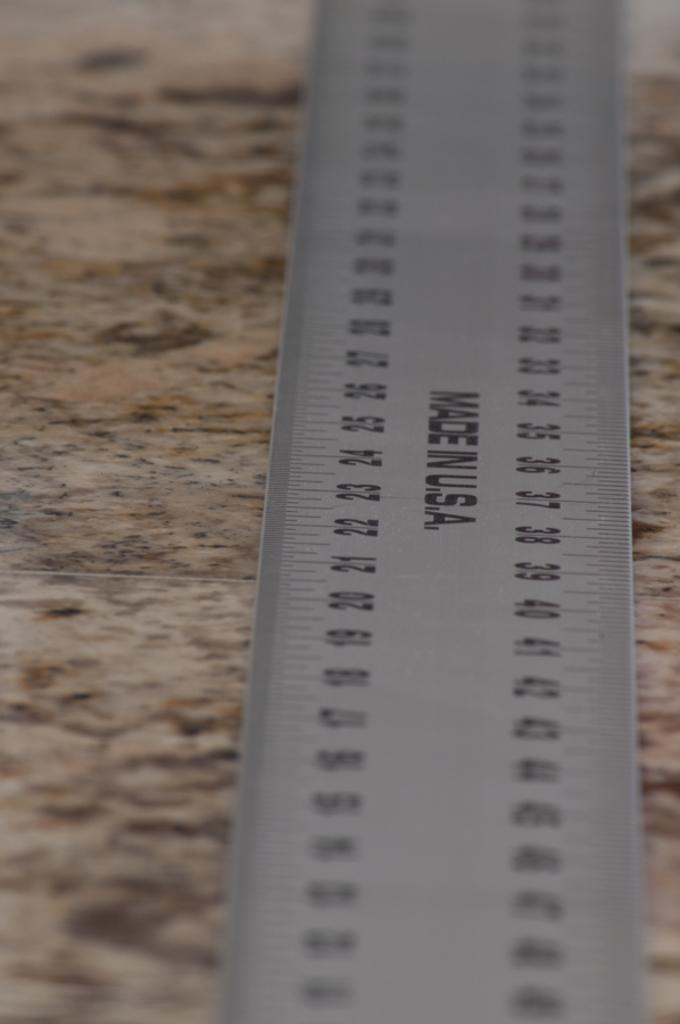Provide a one-sentence caption for the provided image. Ruler with numbers that was made in the USA. 